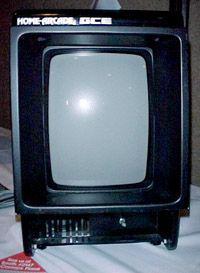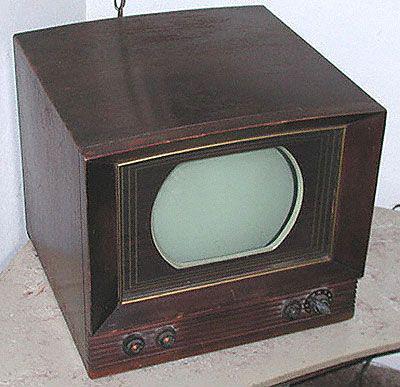The first image is the image on the left, the second image is the image on the right. Examine the images to the left and right. Is the description "Two old televisions have brown cases." accurate? Answer yes or no. No. The first image is the image on the left, the second image is the image on the right. Examine the images to the left and right. Is the description "the controls are right of the screen in the image on the right" accurate? Answer yes or no. No. 